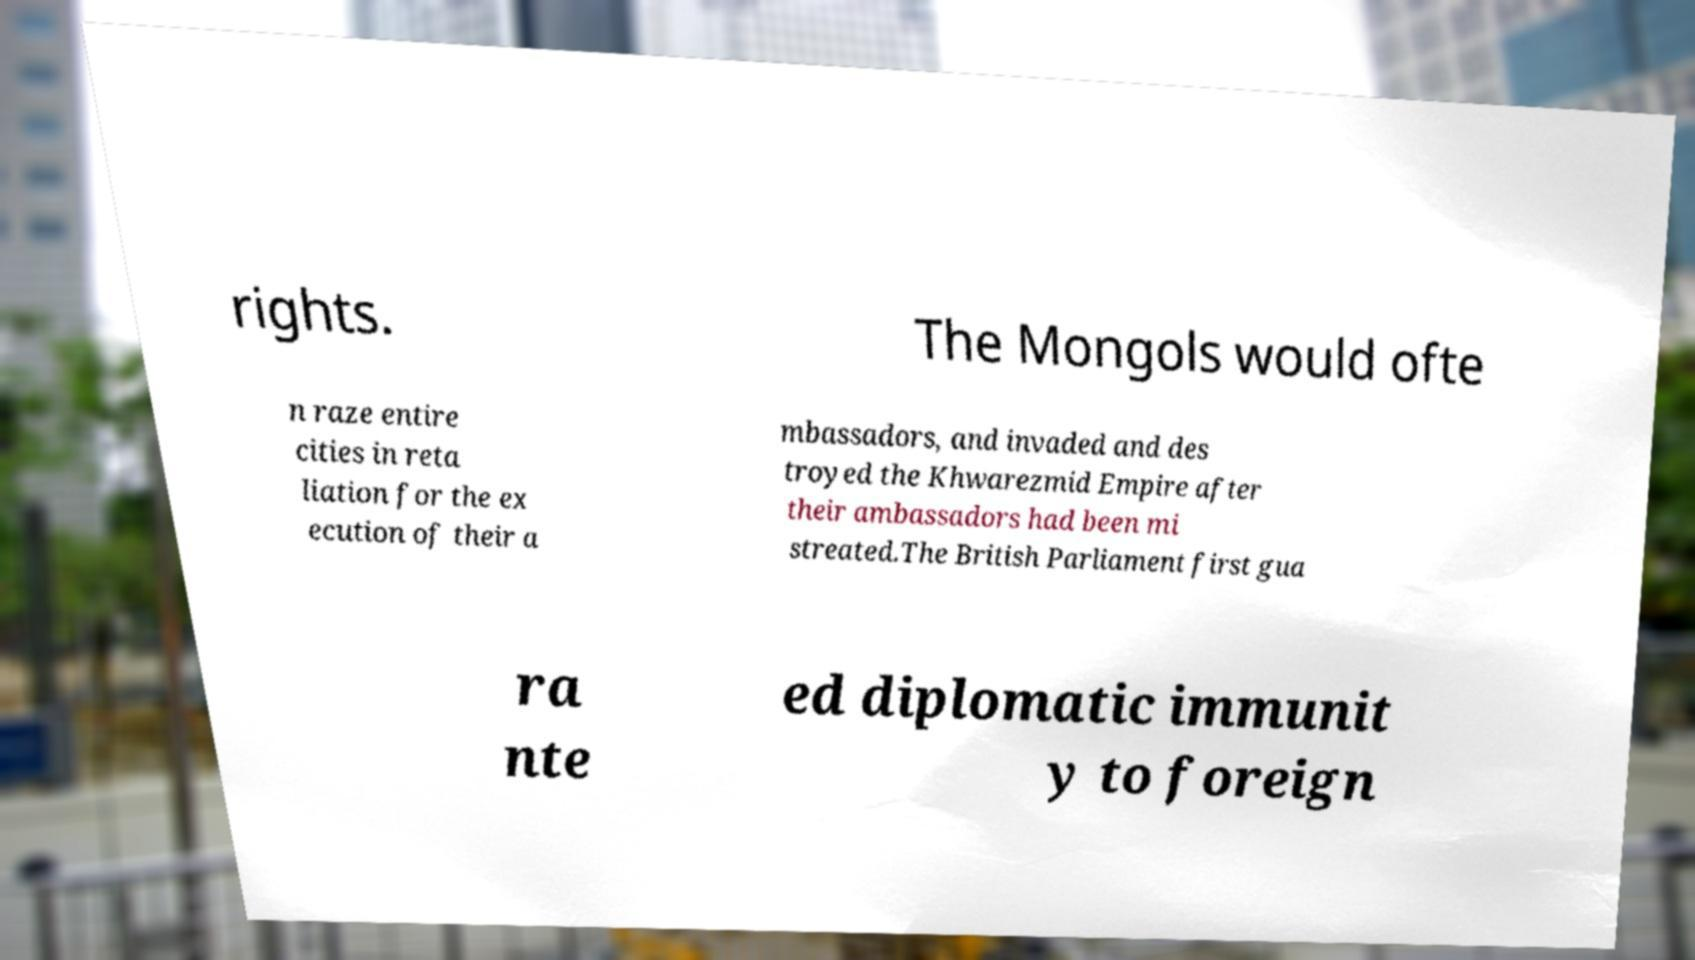There's text embedded in this image that I need extracted. Can you transcribe it verbatim? rights. The Mongols would ofte n raze entire cities in reta liation for the ex ecution of their a mbassadors, and invaded and des troyed the Khwarezmid Empire after their ambassadors had been mi streated.The British Parliament first gua ra nte ed diplomatic immunit y to foreign 